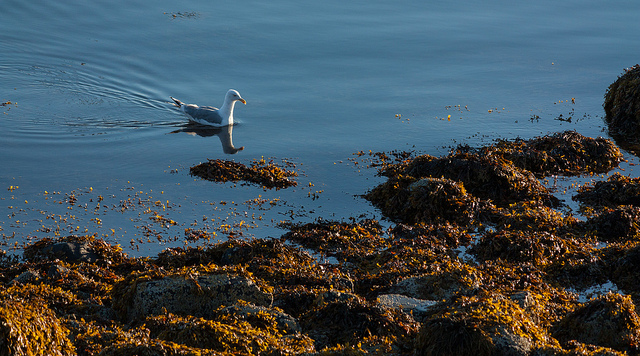How many animals are pictured? In the image, there is one animal visible, a single bird that appears to be a seagull, gracefully floating on the calm water surrounded by seaweed-covered rocks. 